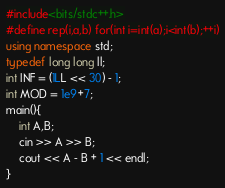<code> <loc_0><loc_0><loc_500><loc_500><_C++_>#include<bits/stdc++.h>
#define rep(i,a,b) for(int i=int(a);i<int(b);++i)
using namespace std;
typedef long long ll;
int INF = (1LL << 30) - 1;
int MOD = 1e9+7;
main(){
    int A,B;
    cin >> A >> B;
    cout << A - B + 1 << endl;
}</code> 